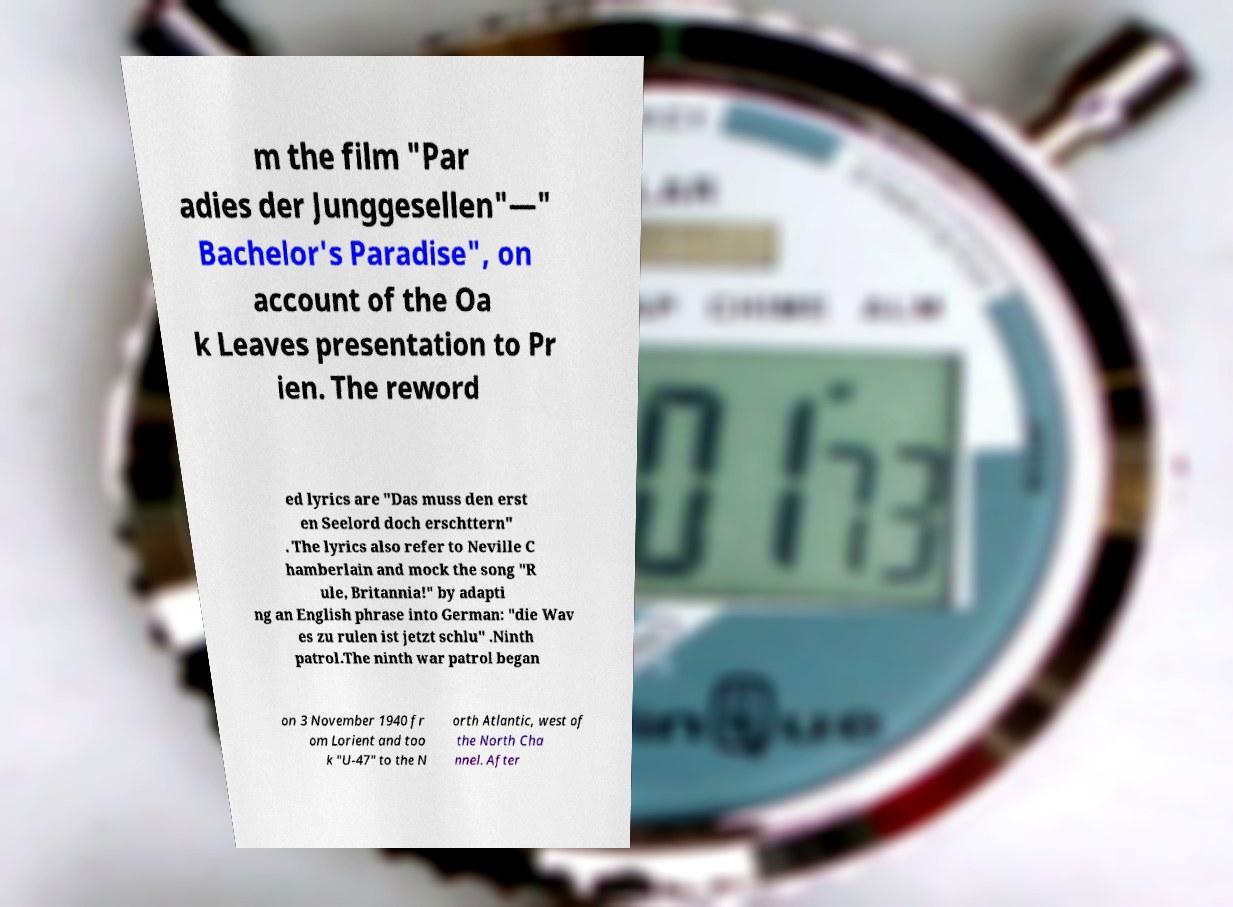Could you assist in decoding the text presented in this image and type it out clearly? m the film "Par adies der Junggesellen"—" Bachelor's Paradise", on account of the Oa k Leaves presentation to Pr ien. The reword ed lyrics are "Das muss den erst en Seelord doch erschttern" . The lyrics also refer to Neville C hamberlain and mock the song "R ule, Britannia!" by adapti ng an English phrase into German: "die Wav es zu rulen ist jetzt schlu" .Ninth patrol.The ninth war patrol began on 3 November 1940 fr om Lorient and too k "U-47" to the N orth Atlantic, west of the North Cha nnel. After 